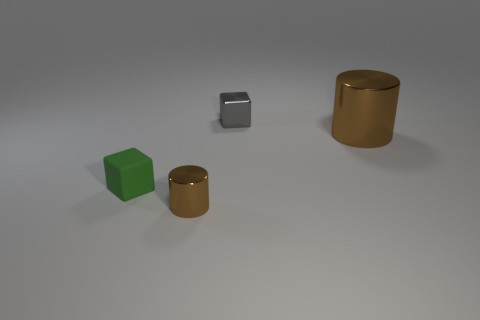Are there an equal number of tiny green blocks that are on the left side of the small rubber object and tiny cubes?
Provide a succinct answer. No. Is there a gray metal object that has the same shape as the matte thing?
Offer a very short reply. Yes. There is a thing that is in front of the large metal cylinder and to the right of the rubber cube; what shape is it?
Give a very brief answer. Cylinder. Are the large object and the brown cylinder that is left of the tiny metal block made of the same material?
Your answer should be very brief. Yes. There is a gray metal thing; are there any brown metal things to the right of it?
Your answer should be very brief. Yes. How many objects are big brown metal cylinders or brown metallic objects to the right of the metal cube?
Keep it short and to the point. 1. There is a object to the left of the cylinder in front of the big thing; what is its color?
Your response must be concise. Green. How many other things are there of the same material as the tiny green thing?
Your answer should be compact. 0. What number of metallic things are gray cubes or large cubes?
Keep it short and to the point. 1. The small shiny object that is the same shape as the green rubber thing is what color?
Your answer should be compact. Gray. 